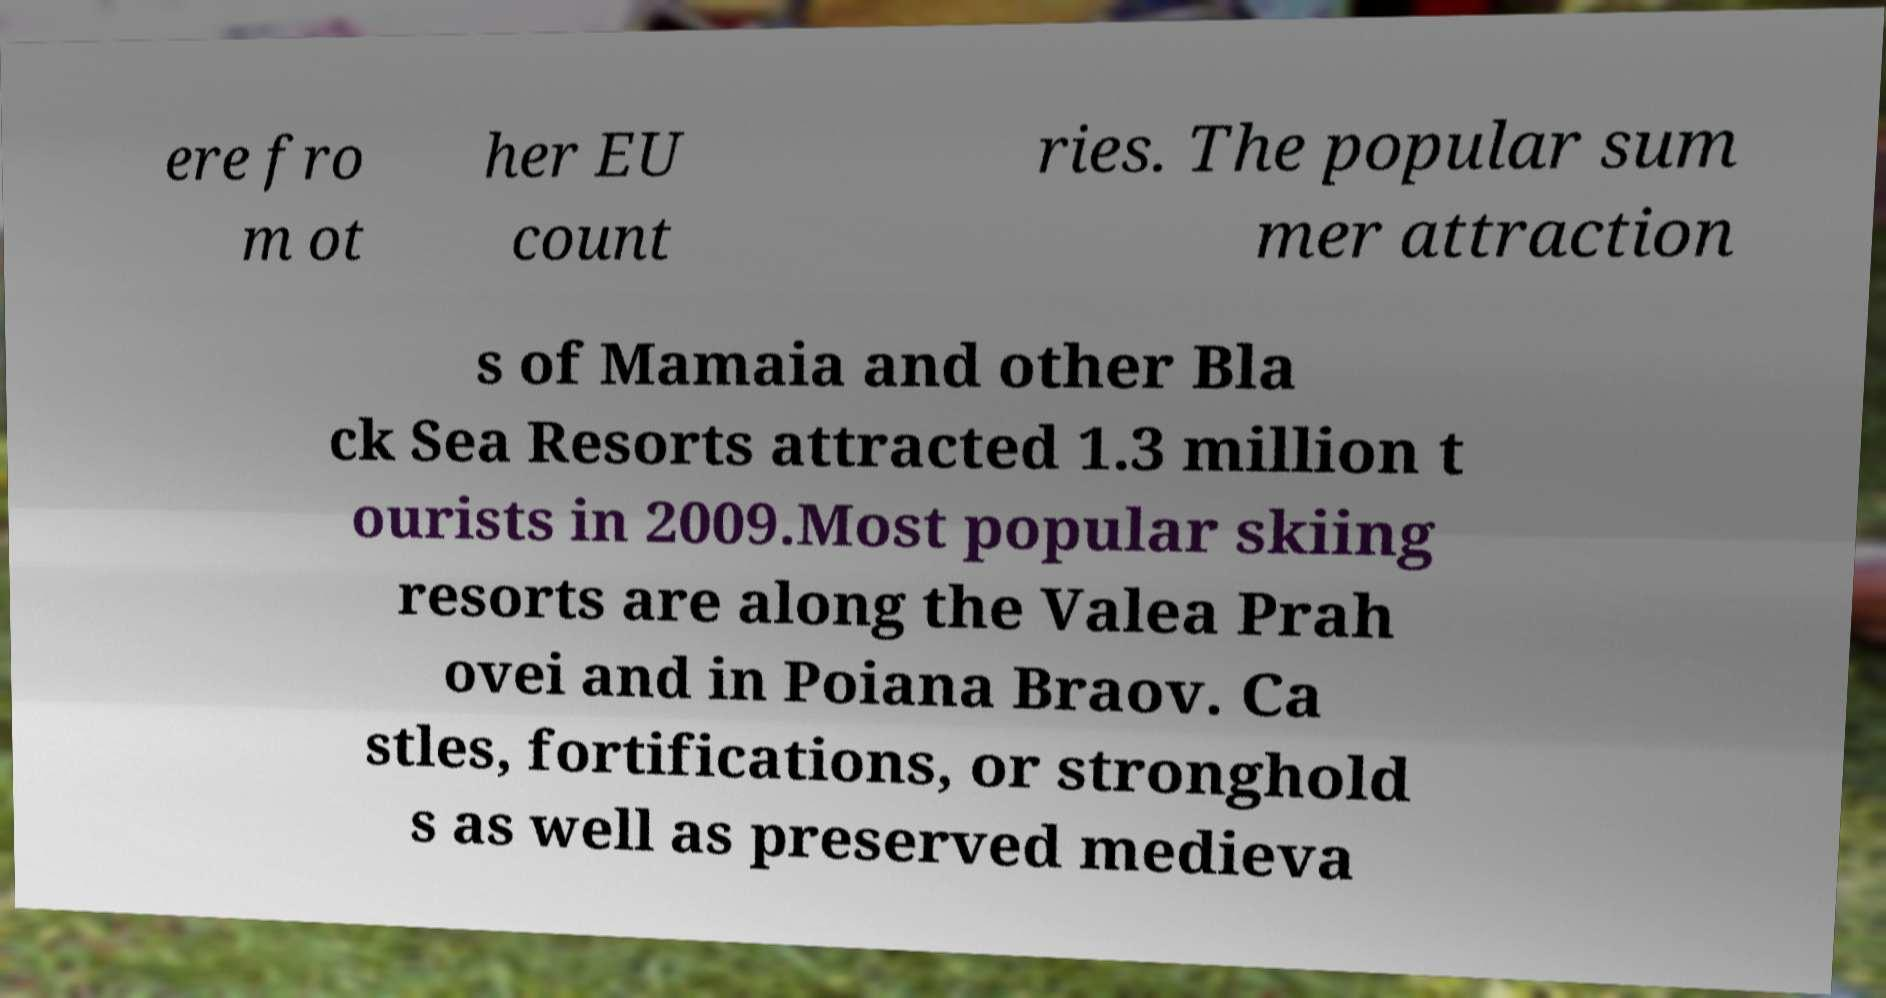Could you extract and type out the text from this image? ere fro m ot her EU count ries. The popular sum mer attraction s of Mamaia and other Bla ck Sea Resorts attracted 1.3 million t ourists in 2009.Most popular skiing resorts are along the Valea Prah ovei and in Poiana Braov. Ca stles, fortifications, or stronghold s as well as preserved medieva 